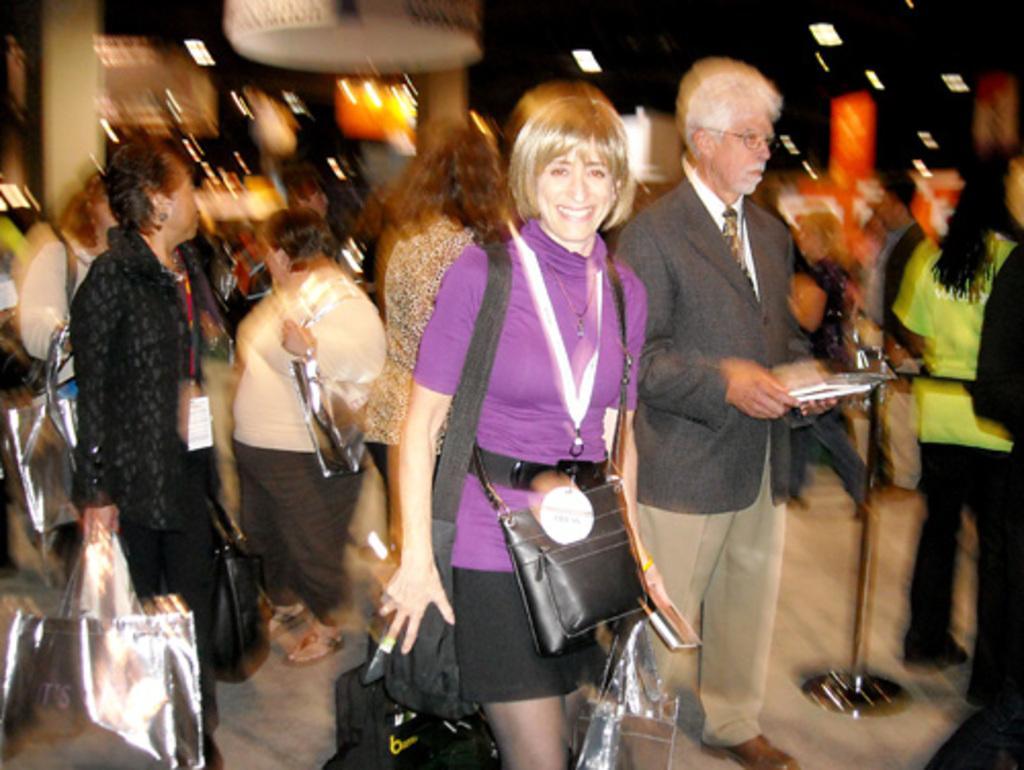In one or two sentences, can you explain what this image depicts? in the picture there is a woman walking back of the women there are many persons 